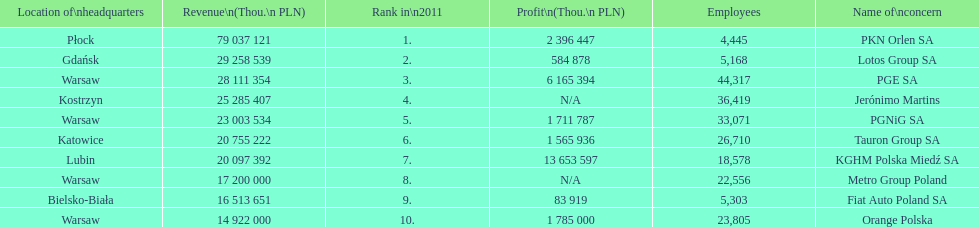Which company had the most revenue? PKN Orlen SA. Help me parse the entirety of this table. {'header': ['Location of\\nheadquarters', 'Revenue\\n(Thou.\\n\xa0PLN)', 'Rank in\\n2011', 'Profit\\n(Thou.\\n\xa0PLN)', 'Employees', 'Name of\\nconcern'], 'rows': [['Płock', '79 037 121', '1.', '2 396 447', '4,445', 'PKN Orlen SA'], ['Gdańsk', '29 258 539', '2.', '584 878', '5,168', 'Lotos Group SA'], ['Warsaw', '28 111 354', '3.', '6 165 394', '44,317', 'PGE SA'], ['Kostrzyn', '25 285 407', '4.', 'N/A', '36,419', 'Jerónimo Martins'], ['Warsaw', '23 003 534', '5.', '1 711 787', '33,071', 'PGNiG SA'], ['Katowice', '20 755 222', '6.', '1 565 936', '26,710', 'Tauron Group SA'], ['Lubin', '20 097 392', '7.', '13 653 597', '18,578', 'KGHM Polska Miedź SA'], ['Warsaw', '17 200 000', '8.', 'N/A', '22,556', 'Metro Group Poland'], ['Bielsko-Biała', '16 513 651', '9.', '83 919', '5,303', 'Fiat Auto Poland SA'], ['Warsaw', '14 922 000', '10.', '1 785 000', '23,805', 'Orange Polska']]} 